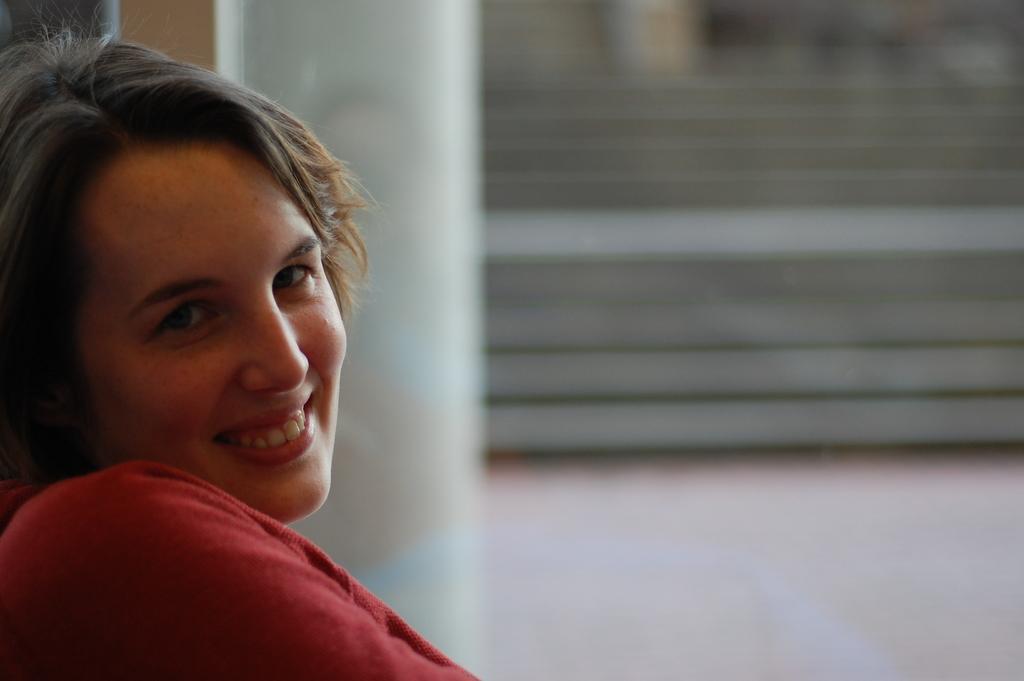In one or two sentences, can you explain what this image depicts? In this image we can see a lady smiling. In the background there are stairs. 